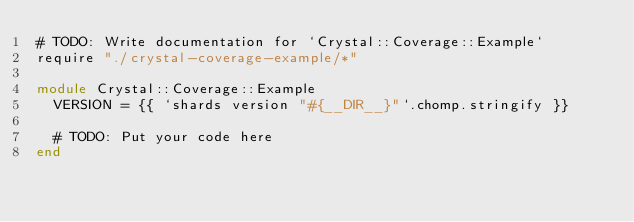Convert code to text. <code><loc_0><loc_0><loc_500><loc_500><_Crystal_># TODO: Write documentation for `Crystal::Coverage::Example`
require "./crystal-coverage-example/*"

module Crystal::Coverage::Example
  VERSION = {{ `shards version "#{__DIR__}"`.chomp.stringify }}

  # TODO: Put your code here
end
</code> 